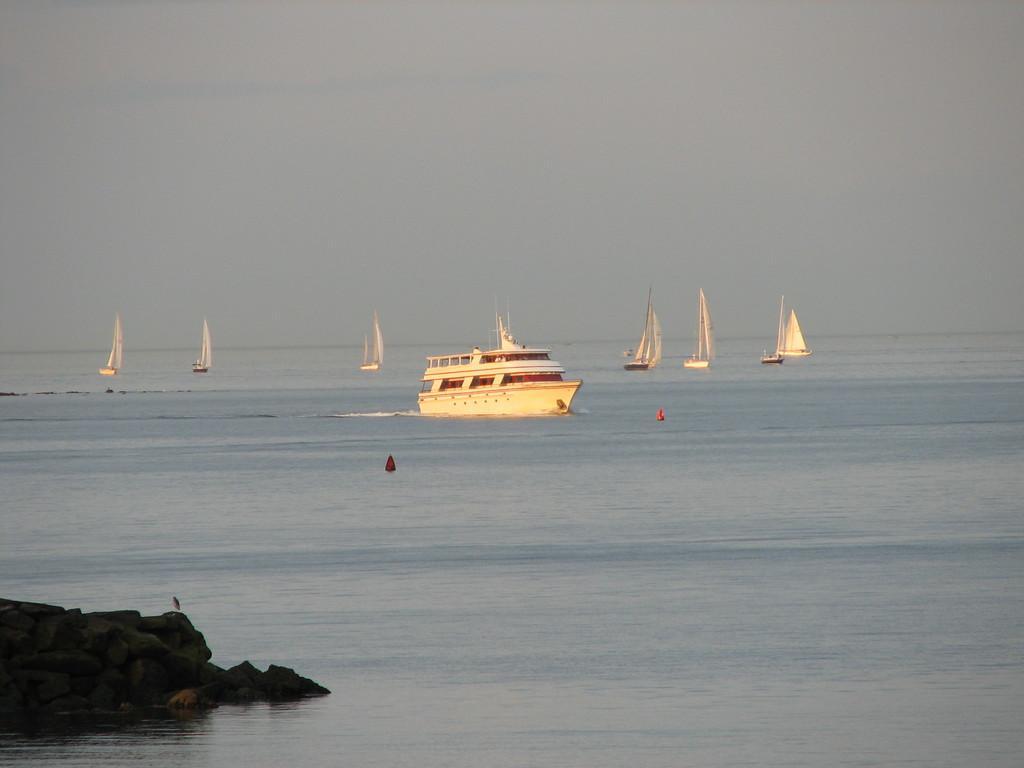In one or two sentences, can you explain what this image depicts? Here in this picture we can see number of boats present in the water and in the front on the left side we can see some stones present on the ground and we can see the sky is cloudy. 